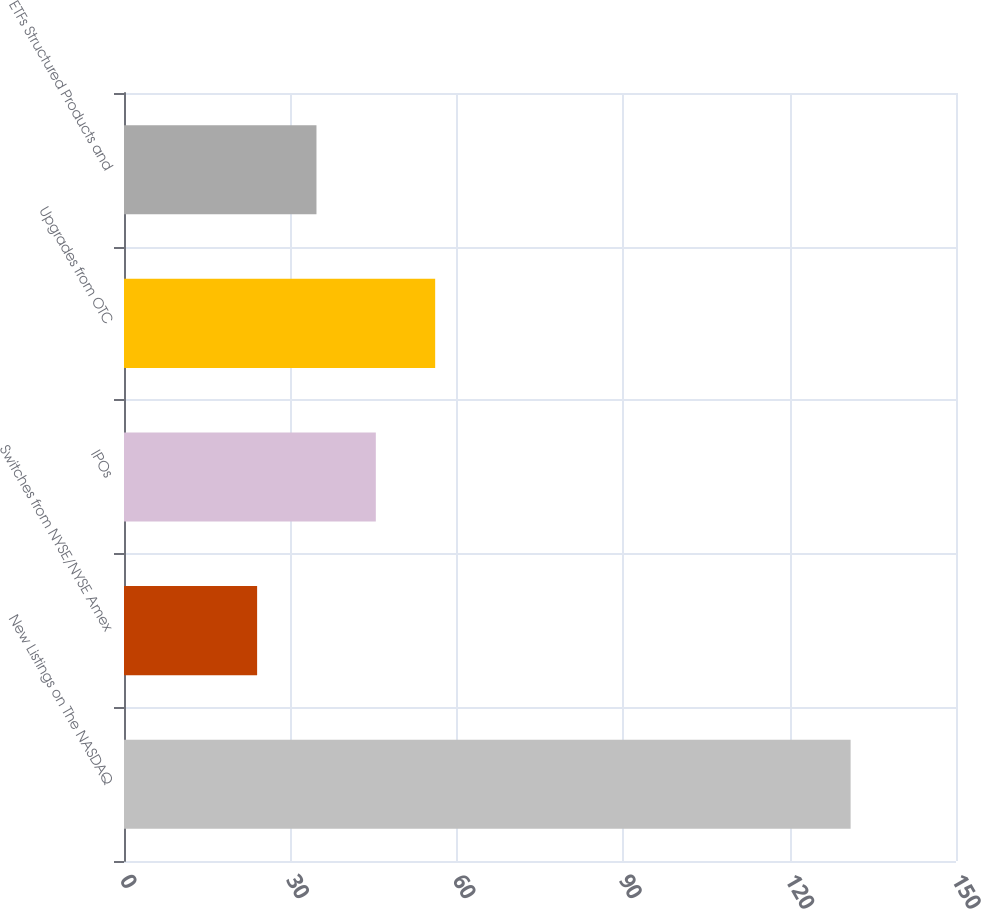Convert chart to OTSL. <chart><loc_0><loc_0><loc_500><loc_500><bar_chart><fcel>New Listings on The NASDAQ<fcel>Switches from NYSE/NYSE Amex<fcel>IPOs<fcel>Upgrades from OTC<fcel>ETFs Structured Products and<nl><fcel>131<fcel>24<fcel>45.4<fcel>56.1<fcel>34.7<nl></chart> 